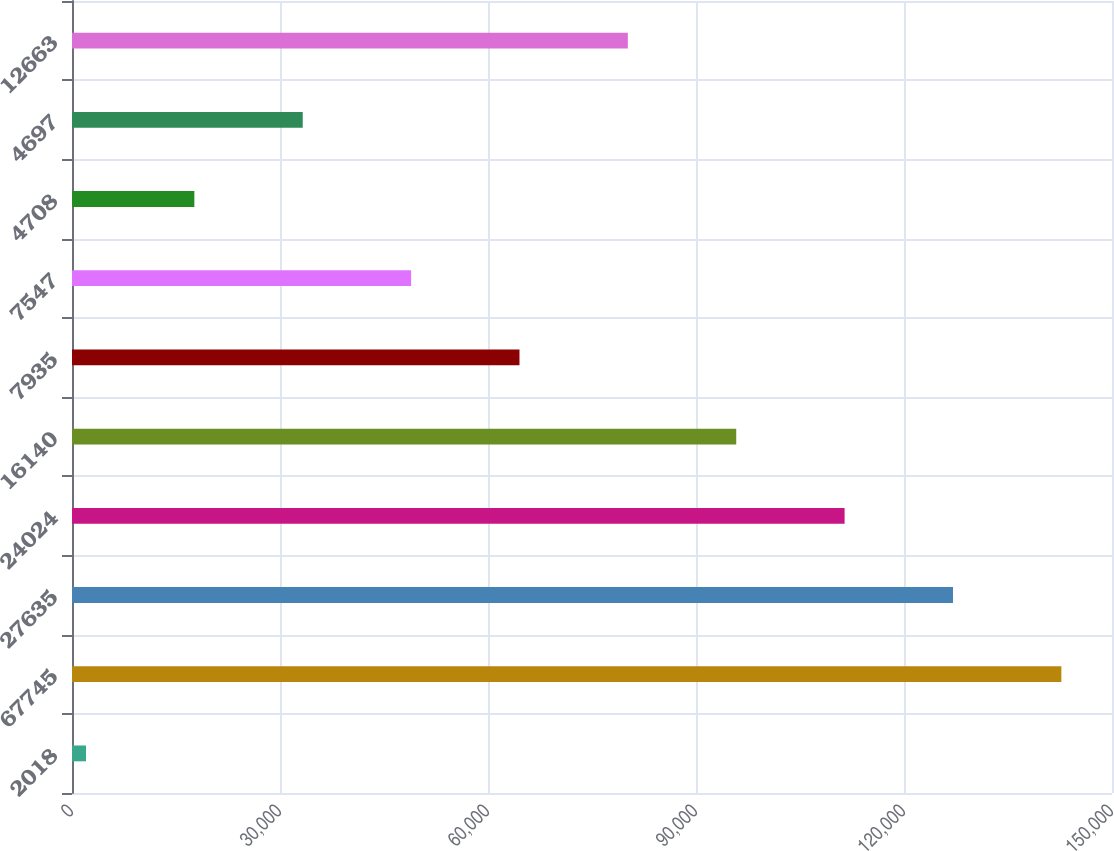<chart> <loc_0><loc_0><loc_500><loc_500><bar_chart><fcel>2018<fcel>67745<fcel>27635<fcel>24024<fcel>16140<fcel>7935<fcel>7547<fcel>4708<fcel>4697<fcel>12663<nl><fcel>2016<fcel>142695<fcel>127064<fcel>111433<fcel>95802<fcel>64540<fcel>48909<fcel>17647<fcel>33278<fcel>80171<nl></chart> 